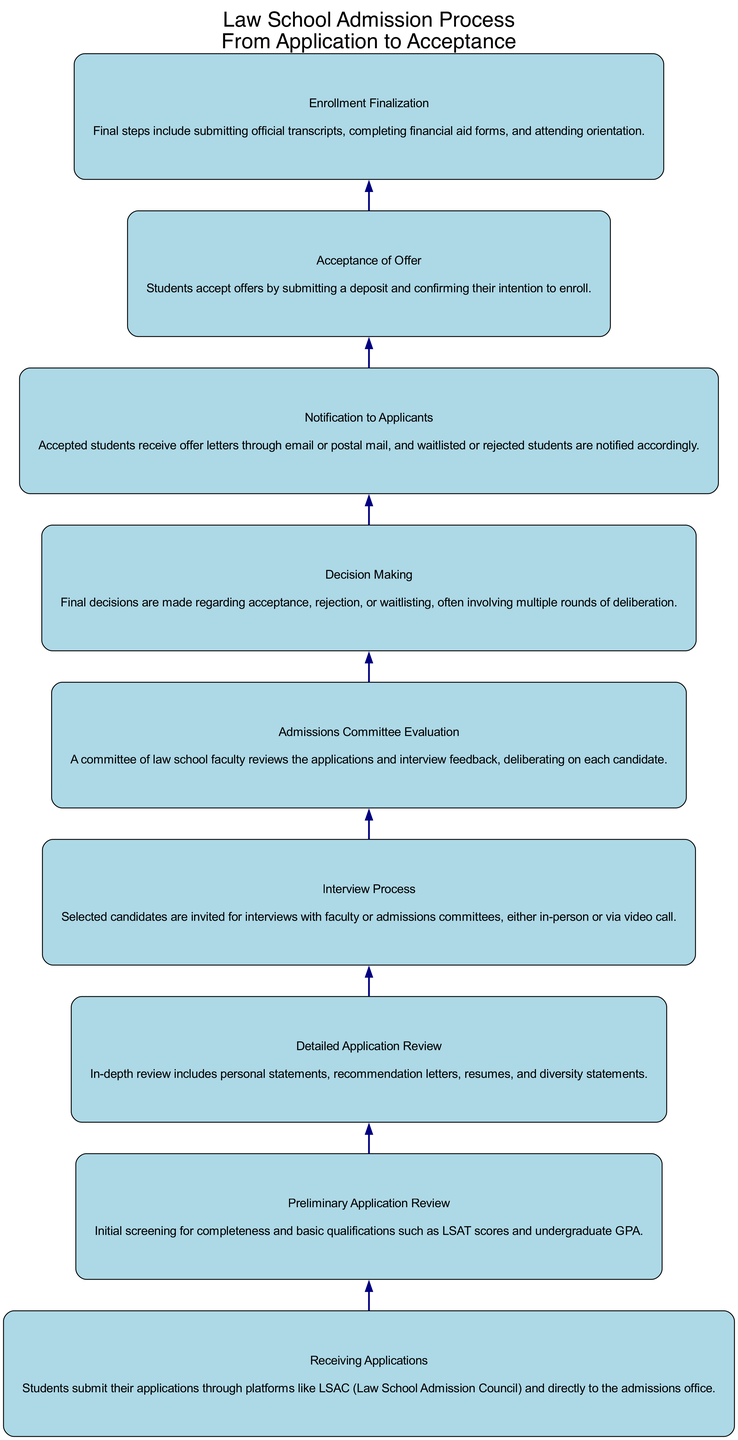What is the first stage in the admission process? The first stage in the diagram is "Receiving Applications", which is listed at the bottom of the flow chart. It indicates the beginning of the process where students submit their applications.
Answer: Receiving Applications How many total stages are there in the admission process? By counting the stages provided in the diagram, we can see there are a total of 9 distinct stages from "Receiving Applications" to "Enrollment Finalization".
Answer: 9 Which stage directly follows "Detailed Application Review"? The diagram shows that "Interview Process" is the stage that comes immediately after "Detailed Application Review", as there is a direct edge connecting these two nodes.
Answer: Interview Process What is the last stage in the admission process? The last stage is identified as "Enrollment Finalization", which is at the top of the flow chart. This indicates that all previous steps culminate in the finalization of enrollment.
Answer: Enrollment Finalization Which stages are involved before the final decision making? The stages involved before "Decision Making" include "Interview Process" and "Admissions Committee Evaluation". Each of these stages contributes to the evaluation before a final decision is reached.
Answer: Interview Process and Admissions Committee Evaluation What events happen after a student is accepted? Following acceptance, the stage "Acceptance of Offer" takes place where students formally accept their offers, leading to their eventual enrollment.
Answer: Acceptance of Offer How are candidates notified of their application status? Candidates are informed of their application status during the "Notification to Applicants" stage, which occurs after the final decisions are made by the admissions committee.
Answer: Notification to Applicants What type of review happens first, preliminary or detailed? The "Preliminary Application Review" happens first in the flow, serving as the initial screening stage before any detailed evaluations occur.
Answer: Preliminary Application Review In the admission process, which step involves interviews? The step involving interviews is the "Interview Process", where selected candidates meet with faculty or admissions committees.
Answer: Interview Process 